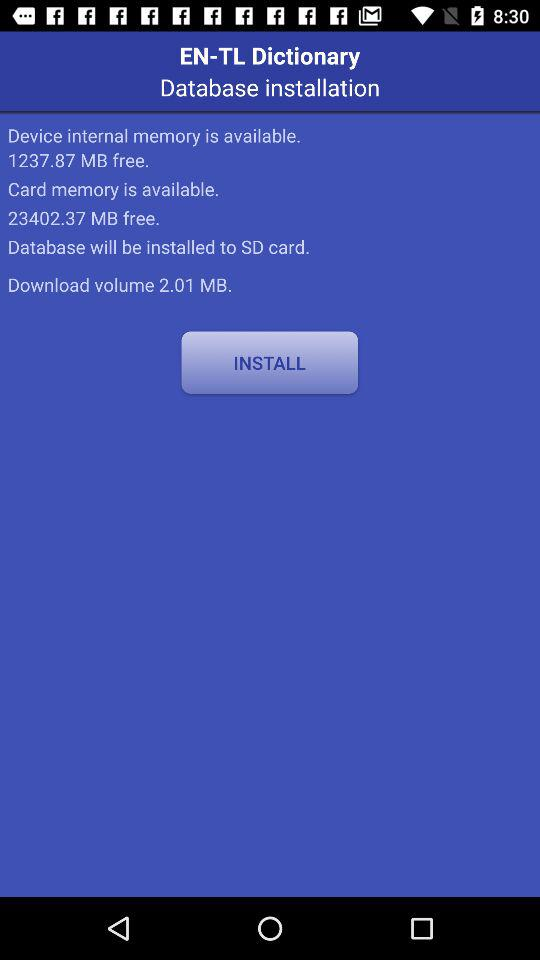What is the download volume? The download volume is 2.01 MB. 